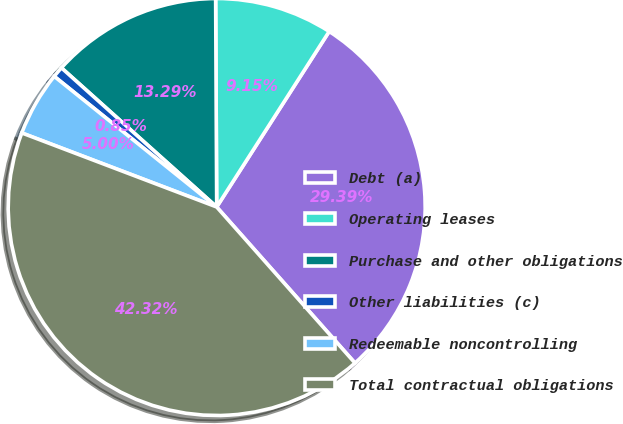<chart> <loc_0><loc_0><loc_500><loc_500><pie_chart><fcel>Debt (a)<fcel>Operating leases<fcel>Purchase and other obligations<fcel>Other liabilities (c)<fcel>Redeemable noncontrolling<fcel>Total contractual obligations<nl><fcel>29.39%<fcel>9.15%<fcel>13.29%<fcel>0.85%<fcel>5.0%<fcel>42.32%<nl></chart> 